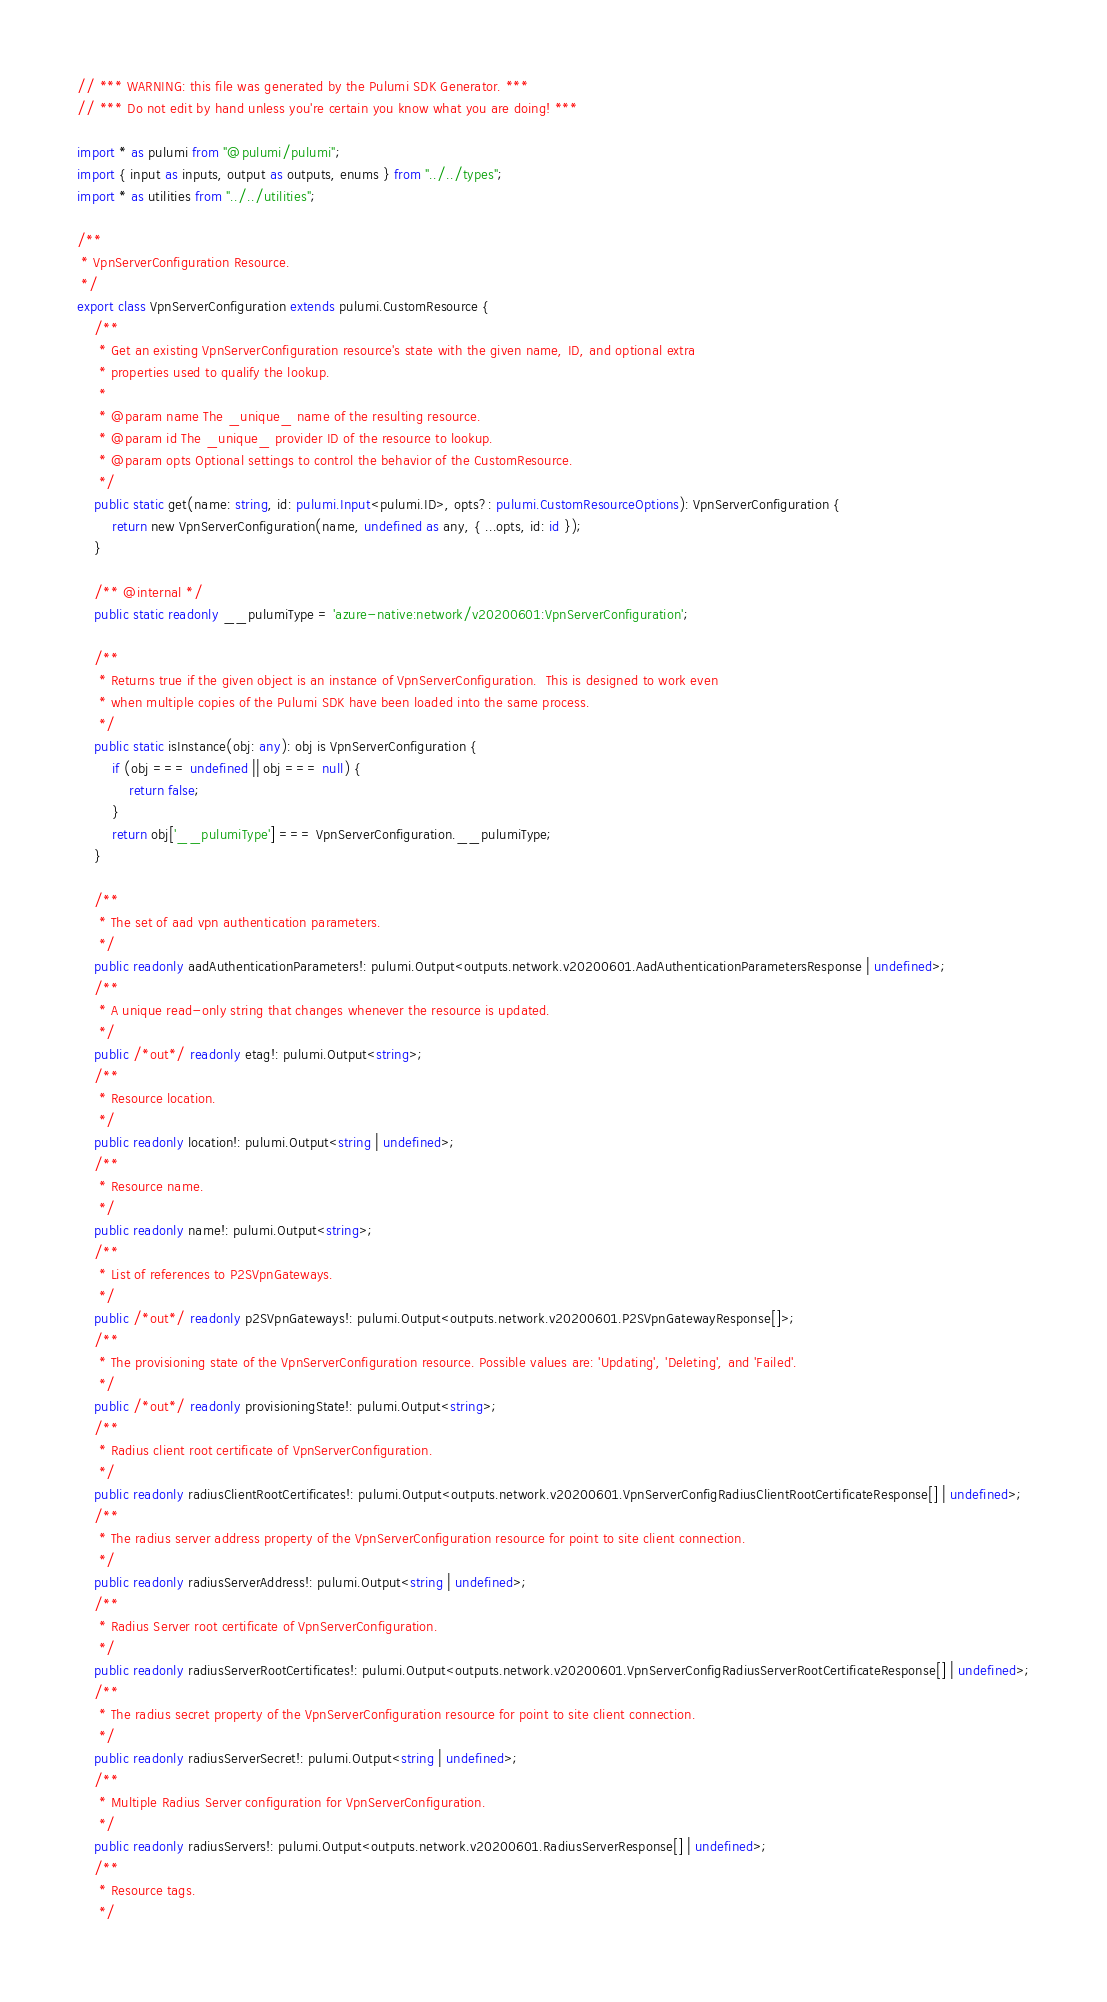<code> <loc_0><loc_0><loc_500><loc_500><_TypeScript_>// *** WARNING: this file was generated by the Pulumi SDK Generator. ***
// *** Do not edit by hand unless you're certain you know what you are doing! ***

import * as pulumi from "@pulumi/pulumi";
import { input as inputs, output as outputs, enums } from "../../types";
import * as utilities from "../../utilities";

/**
 * VpnServerConfiguration Resource.
 */
export class VpnServerConfiguration extends pulumi.CustomResource {
    /**
     * Get an existing VpnServerConfiguration resource's state with the given name, ID, and optional extra
     * properties used to qualify the lookup.
     *
     * @param name The _unique_ name of the resulting resource.
     * @param id The _unique_ provider ID of the resource to lookup.
     * @param opts Optional settings to control the behavior of the CustomResource.
     */
    public static get(name: string, id: pulumi.Input<pulumi.ID>, opts?: pulumi.CustomResourceOptions): VpnServerConfiguration {
        return new VpnServerConfiguration(name, undefined as any, { ...opts, id: id });
    }

    /** @internal */
    public static readonly __pulumiType = 'azure-native:network/v20200601:VpnServerConfiguration';

    /**
     * Returns true if the given object is an instance of VpnServerConfiguration.  This is designed to work even
     * when multiple copies of the Pulumi SDK have been loaded into the same process.
     */
    public static isInstance(obj: any): obj is VpnServerConfiguration {
        if (obj === undefined || obj === null) {
            return false;
        }
        return obj['__pulumiType'] === VpnServerConfiguration.__pulumiType;
    }

    /**
     * The set of aad vpn authentication parameters.
     */
    public readonly aadAuthenticationParameters!: pulumi.Output<outputs.network.v20200601.AadAuthenticationParametersResponse | undefined>;
    /**
     * A unique read-only string that changes whenever the resource is updated.
     */
    public /*out*/ readonly etag!: pulumi.Output<string>;
    /**
     * Resource location.
     */
    public readonly location!: pulumi.Output<string | undefined>;
    /**
     * Resource name.
     */
    public readonly name!: pulumi.Output<string>;
    /**
     * List of references to P2SVpnGateways.
     */
    public /*out*/ readonly p2SVpnGateways!: pulumi.Output<outputs.network.v20200601.P2SVpnGatewayResponse[]>;
    /**
     * The provisioning state of the VpnServerConfiguration resource. Possible values are: 'Updating', 'Deleting', and 'Failed'.
     */
    public /*out*/ readonly provisioningState!: pulumi.Output<string>;
    /**
     * Radius client root certificate of VpnServerConfiguration.
     */
    public readonly radiusClientRootCertificates!: pulumi.Output<outputs.network.v20200601.VpnServerConfigRadiusClientRootCertificateResponse[] | undefined>;
    /**
     * The radius server address property of the VpnServerConfiguration resource for point to site client connection.
     */
    public readonly radiusServerAddress!: pulumi.Output<string | undefined>;
    /**
     * Radius Server root certificate of VpnServerConfiguration.
     */
    public readonly radiusServerRootCertificates!: pulumi.Output<outputs.network.v20200601.VpnServerConfigRadiusServerRootCertificateResponse[] | undefined>;
    /**
     * The radius secret property of the VpnServerConfiguration resource for point to site client connection.
     */
    public readonly radiusServerSecret!: pulumi.Output<string | undefined>;
    /**
     * Multiple Radius Server configuration for VpnServerConfiguration.
     */
    public readonly radiusServers!: pulumi.Output<outputs.network.v20200601.RadiusServerResponse[] | undefined>;
    /**
     * Resource tags.
     */</code> 